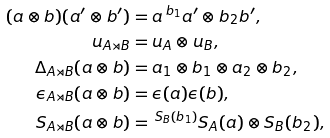Convert formula to latex. <formula><loc_0><loc_0><loc_500><loc_500>( a \otimes b ) ( a ^ { \prime } \otimes b ^ { \prime } ) & = a \, ^ { b _ { 1 } } a ^ { \prime } \otimes b _ { 2 } b ^ { \prime } , \\ u _ { A \rtimes B } & = u _ { A } \otimes u _ { B } , \\ \Delta _ { A \rtimes B } ( a \otimes b ) & = a _ { 1 } \otimes b _ { 1 } \otimes a _ { 2 } \otimes b _ { 2 } , \\ \epsilon _ { A \rtimes B } ( a \otimes b ) & = \epsilon ( a ) \epsilon ( b ) , \\ S _ { A \rtimes B } ( a \otimes b ) & = \, ^ { S _ { B } ( b _ { 1 } ) } S _ { A } ( a ) \otimes S _ { B } ( b _ { 2 } ) ,</formula> 